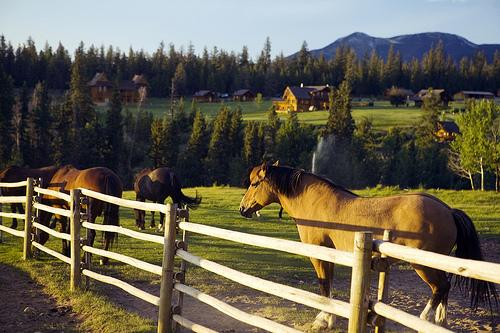Based on the context of the image, what kind of sentiment does the scene convey? The scene conveys a calm and serene sentiment, with horses leisurely walking in a beautiful, sunlit pasture surrounded by trees, houses, and mountains. Provide a brief overview of the general setting and its elements in this image. The image shows a group of brown horses walking in a green field, with a wooden fence, trees, houses, and mountains in the background. Which type of fence is surrounding the horses in the image? The horses are surrounded by a wooden fence. What are the structures that can be observed behind the horses? There are houses in the distance, surrounded by green trees and tall mountains in the background. Identify the primary colors of the horses in the image. The horses are primarily brown with black manes and tails, and some have white on their feet. Examine the sprinkler in the image and describe its effect on the surroundings. Water from the sprinkler is seen spraying onto the green grass, keeping it fresh and lush. Count the number of horses in the image, and detail any distinctive features they may have. There are four horses in the image, with brown bodies, black manes and tails, and some have white on their feet. What kind of trees can be seen in the background, and what color are they? There are green trees in the background, forming a line. What do you observe about sunlight in the image and its effect on the elements? The sun is shining on the horses and one of the houses, brightening the scene and creating a positive atmosphere. Describe the position of the houses in relation to the horse and the trees. The houses are in between two tree lines and in the distance behind the horses. Is the sky visible and filled with clouds? No, it's not mentioned in the image. Is there a person standing near the wooden fence? None of the annotations mention the presence of any person in the image. 